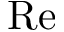<formula> <loc_0><loc_0><loc_500><loc_500>R e</formula> 